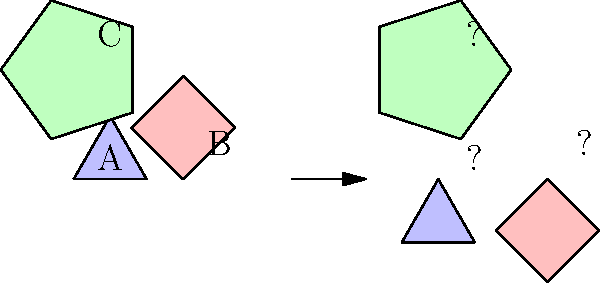In this pattern-matching puzzle, three shapes (A, B, and C) are shown on the left side. On the right side, these shapes have been rotated. Your task is to determine the correct rotation angle for each shape. What is the rotation angle for shape B (the square)? To solve this problem, let's analyze each shape step-by-step:

1. Shape A (Triangle):
   - Original position: Base horizontal, apex pointing up
   - Rotated position: Base at 60° counterclockwise from horizontal
   - Rotation angle: 240° clockwise (or 120° counterclockwise)

2. Shape B (Square):
   - Original position: Rotated 45° clockwise from standard orientation
   - Rotated position: Sides parallel to horizontal and vertical axes
   - Rotation angle: 225° clockwise (or 45° counterclockwise)

3. Shape C (Pentagon):
   - Original position: One vertex pointing up, slightly rotated clockwise
   - Rotated position: One side horizontal at the bottom
   - Rotation angle: 198° clockwise (or 162° counterclockwise)

The question specifically asks for the rotation angle of Shape B (the square). We determined that it was rotated 225° clockwise from its original position.
Answer: 225° 